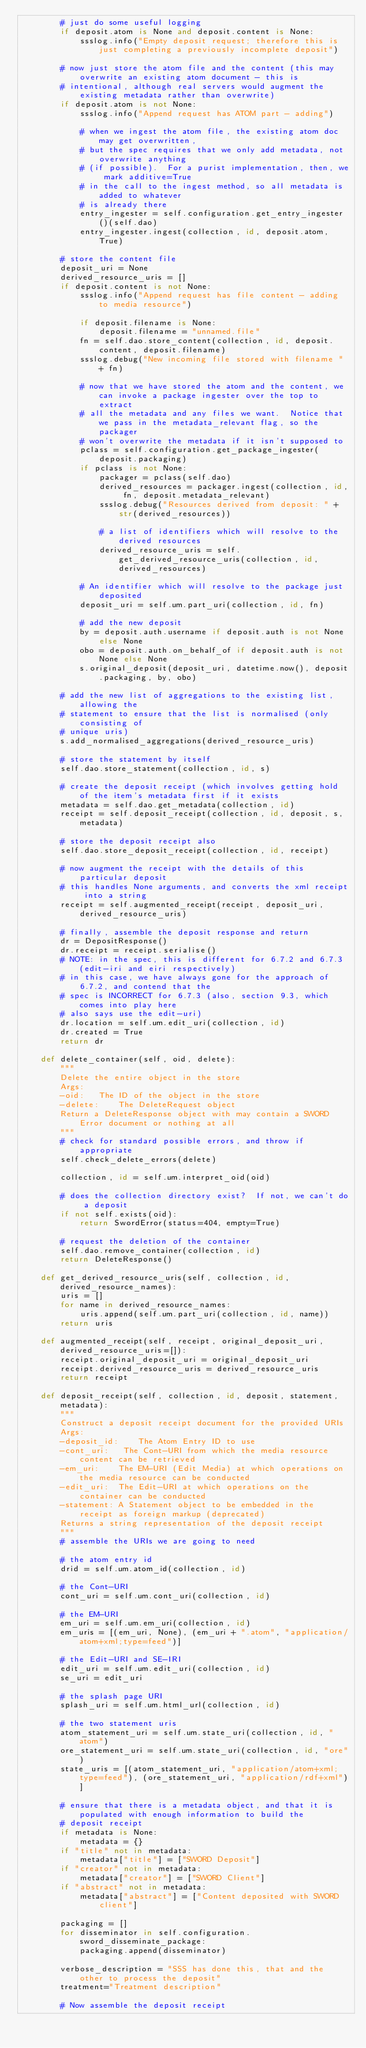<code> <loc_0><loc_0><loc_500><loc_500><_Python_>        # just do some useful logging
        if deposit.atom is None and deposit.content is None:
            ssslog.info("Empty deposit request; therefore this is just completing a previously incomplete deposit")
        
        # now just store the atom file and the content (this may overwrite an existing atom document - this is
        # intentional, although real servers would augment the existing metadata rather than overwrite)
        if deposit.atom is not None:
            ssslog.info("Append request has ATOM part - adding")
            
            # when we ingest the atom file, the existing atom doc may get overwritten,
            # but the spec requires that we only add metadata, not overwrite anything
            # (if possible).  For a purist implementation, then, we mark additive=True
            # in the call to the ingest method, so all metadata is added to whatever
            # is already there
            entry_ingester = self.configuration.get_entry_ingester()(self.dao)
            entry_ingester.ingest(collection, id, deposit.atom, True)

        # store the content file
        deposit_uri = None
        derived_resource_uris = []
        if deposit.content is not None:
            ssslog.info("Append request has file content - adding to media resource")
            
            if deposit.filename is None:
                deposit.filename = "unnamed.file"
            fn = self.dao.store_content(collection, id, deposit.content, deposit.filename)
            ssslog.debug("New incoming file stored with filename " + fn)

            # now that we have stored the atom and the content, we can invoke a package ingester over the top to extract
            # all the metadata and any files we want.  Notice that we pass in the metadata_relevant flag, so the packager
            # won't overwrite the metadata if it isn't supposed to
            pclass = self.configuration.get_package_ingester(deposit.packaging)
            if pclass is not None:
                packager = pclass(self.dao)
                derived_resources = packager.ingest(collection, id, fn, deposit.metadata_relevant)
                ssslog.debug("Resources derived from deposit: " + str(derived_resources))
                
                # a list of identifiers which will resolve to the derived resources
                derived_resource_uris = self.get_derived_resource_uris(collection, id, derived_resources)

            # An identifier which will resolve to the package just deposited
            deposit_uri = self.um.part_uri(collection, id, fn)

            # add the new deposit
            by = deposit.auth.username if deposit.auth is not None else None
            obo = deposit.auth.on_behalf_of if deposit.auth is not None else None
            s.original_deposit(deposit_uri, datetime.now(), deposit.packaging, by, obo)
        
        # add the new list of aggregations to the existing list, allowing the
        # statement to ensure that the list is normalised (only consisting of
        # unique uris)
        s.add_normalised_aggregations(derived_resource_uris)
        
        # store the statement by itself
        self.dao.store_statement(collection, id, s)

        # create the deposit receipt (which involves getting hold of the item's metadata first if it exists
        metadata = self.dao.get_metadata(collection, id)
        receipt = self.deposit_receipt(collection, id, deposit, s, metadata)

        # store the deposit receipt also
        self.dao.store_deposit_receipt(collection, id, receipt)
        
        # now augment the receipt with the details of this particular deposit
        # this handles None arguments, and converts the xml receipt into a string
        receipt = self.augmented_receipt(receipt, deposit_uri, derived_resource_uris)

        # finally, assemble the deposit response and return
        dr = DepositResponse()
        dr.receipt = receipt.serialise()
        # NOTE: in the spec, this is different for 6.7.2 and 6.7.3 (edit-iri and eiri respectively)
        # in this case, we have always gone for the approach of 6.7.2, and contend that the
        # spec is INCORRECT for 6.7.3 (also, section 9.3, which comes into play here
        # also says use the edit-uri)
        dr.location = self.um.edit_uri(collection, id) 
        dr.created = True
        return dr

    def delete_container(self, oid, delete):
        """
        Delete the entire object in the store
        Args:
        -oid:   The ID of the object in the store
        -delete:    The DeleteRequest object
        Return a DeleteResponse object with may contain a SWORD Error document or nothing at all
        """
        # check for standard possible errors, and throw if appropriate
        self.check_delete_errors(delete)
            
        collection, id = self.um.interpret_oid(oid)

        # does the collection directory exist?  If not, we can't do a deposit
        if not self.exists(oid):
            return SwordError(status=404, empty=True)

        # request the deletion of the container
        self.dao.remove_container(collection, id)
        return DeleteResponse()

    def get_derived_resource_uris(self, collection, id, derived_resource_names):
        uris = []
        for name in derived_resource_names:
            uris.append(self.um.part_uri(collection, id, name))
        return uris

    def augmented_receipt(self, receipt, original_deposit_uri, derived_resource_uris=[]):
        receipt.original_deposit_uri = original_deposit_uri
        receipt.derived_resource_uris = derived_resource_uris     
        return receipt

    def deposit_receipt(self, collection, id, deposit, statement, metadata):
        """
        Construct a deposit receipt document for the provided URIs
        Args:
        -deposit_id:    The Atom Entry ID to use
        -cont_uri:   The Cont-URI from which the media resource content can be retrieved
        -em_uri:    The EM-URI (Edit Media) at which operations on the media resource can be conducted
        -edit_uri:  The Edit-URI at which operations on the container can be conducted
        -statement: A Statement object to be embedded in the receipt as foreign markup (deprecated)
        Returns a string representation of the deposit receipt
        """
        # assemble the URIs we are going to need
        
        # the atom entry id
        drid = self.um.atom_id(collection, id)

        # the Cont-URI
        cont_uri = self.um.cont_uri(collection, id)

        # the EM-URI 
        em_uri = self.um.em_uri(collection, id)
        em_uris = [(em_uri, None), (em_uri + ".atom", "application/atom+xml;type=feed")]

        # the Edit-URI and SE-IRI
        edit_uri = self.um.edit_uri(collection, id)
        se_uri = edit_uri

        # the splash page URI
        splash_uri = self.um.html_url(collection, id)

        # the two statement uris
        atom_statement_uri = self.um.state_uri(collection, id, "atom")
        ore_statement_uri = self.um.state_uri(collection, id, "ore")
        state_uris = [(atom_statement_uri, "application/atom+xml;type=feed"), (ore_statement_uri, "application/rdf+xml")]

        # ensure that there is a metadata object, and that it is populated with enough information to build the
        # deposit receipt
        if metadata is None:
            metadata = {}
        if "title" not in metadata:
            metadata["title"] = ["SWORD Deposit"]
        if "creator" not in metadata:
            metadata["creator"] = ["SWORD Client"]
        if "abstract" not in metadata:
            metadata["abstract"] = ["Content deposited with SWORD client"]

        packaging = []
        for disseminator in self.configuration.sword_disseminate_package:
            packaging.append(disseminator)

        verbose_description = "SSS has done this, that and the other to process the deposit"
        treatment="Treatment description"

        # Now assemble the deposit receipt</code> 